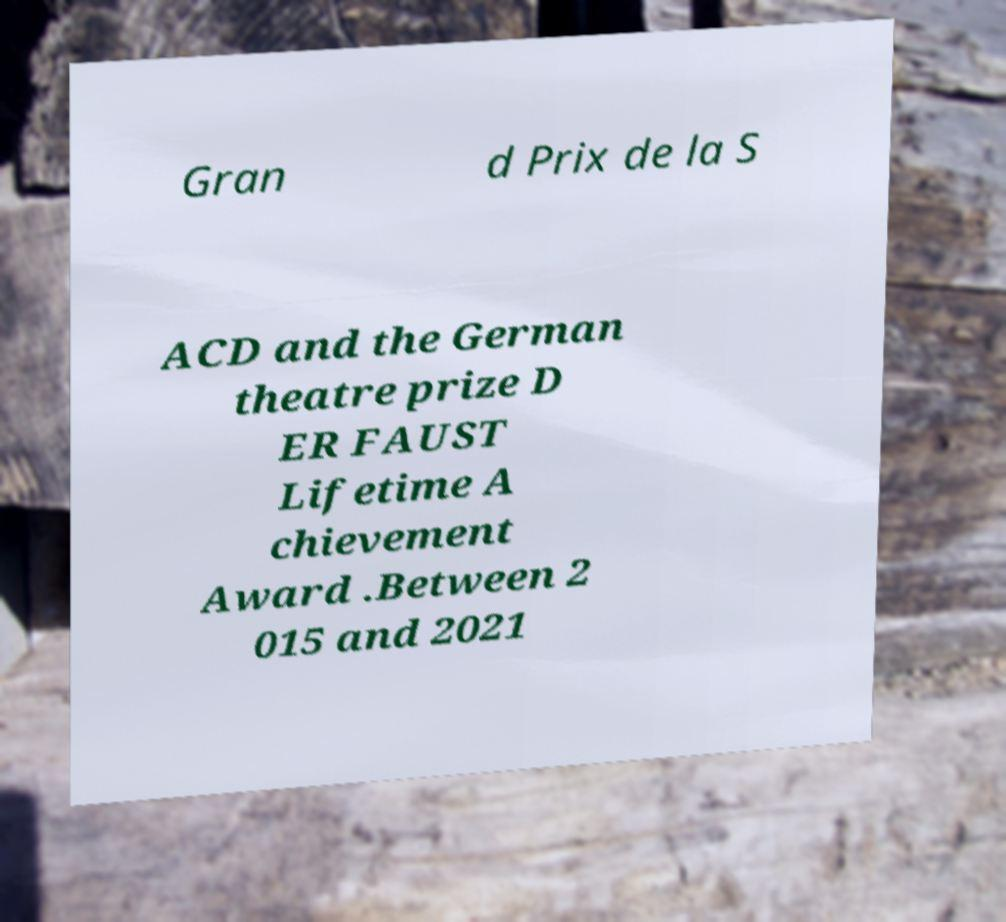Could you assist in decoding the text presented in this image and type it out clearly? Gran d Prix de la S ACD and the German theatre prize D ER FAUST Lifetime A chievement Award .Between 2 015 and 2021 